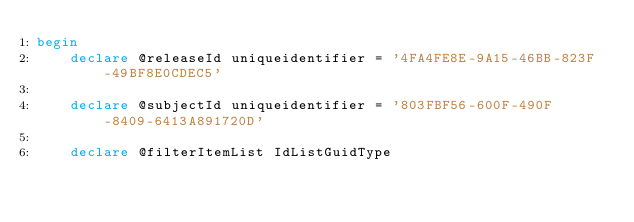<code> <loc_0><loc_0><loc_500><loc_500><_SQL_>begin
    declare @releaseId uniqueidentifier = '4FA4FE8E-9A15-46BB-823F-49BF8E0CDEC5'

    declare @subjectId uniqueidentifier = '803FBF56-600F-490F-8409-6413A891720D'

    declare @filterItemList IdListGuidType</code> 